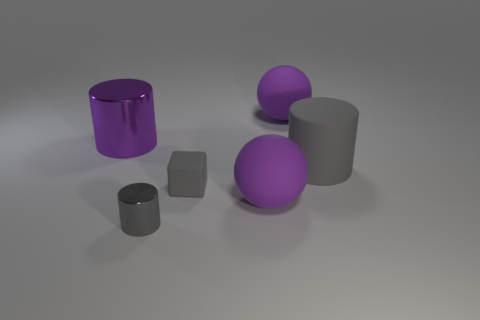There is another metallic object that is the same shape as the tiny metallic object; what is its color?
Ensure brevity in your answer.  Purple. Does the small gray metallic thing have the same shape as the purple metal thing?
Ensure brevity in your answer.  Yes. The big purple ball that is behind the metal object that is behind the tiny gray matte cube is made of what material?
Provide a succinct answer. Rubber. There is a thing that is made of the same material as the purple cylinder; what size is it?
Your answer should be compact. Small. Is there any other thing of the same color as the tiny rubber thing?
Provide a succinct answer. Yes. What is the color of the large cylinder that is to the right of the big purple cylinder?
Your response must be concise. Gray. Is there a big purple metallic thing behind the rubber ball that is in front of the big purple thing on the left side of the small gray metal thing?
Keep it short and to the point. Yes. Are there more tiny objects right of the tiny cylinder than small metallic balls?
Give a very brief answer. Yes. There is a metal thing to the right of the big purple metal cylinder; is it the same shape as the big gray thing?
Provide a short and direct response. Yes. What number of things are large gray shiny spheres or large purple balls that are in front of the big purple cylinder?
Offer a very short reply. 1. 